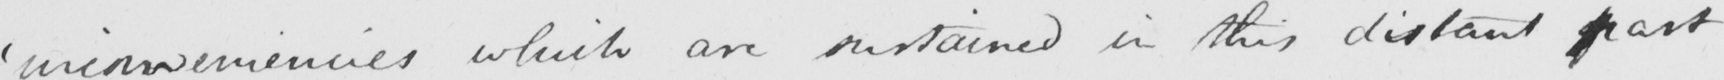Please transcribe the handwritten text in this image. ' inconveniencies which are sustained in this distant part 